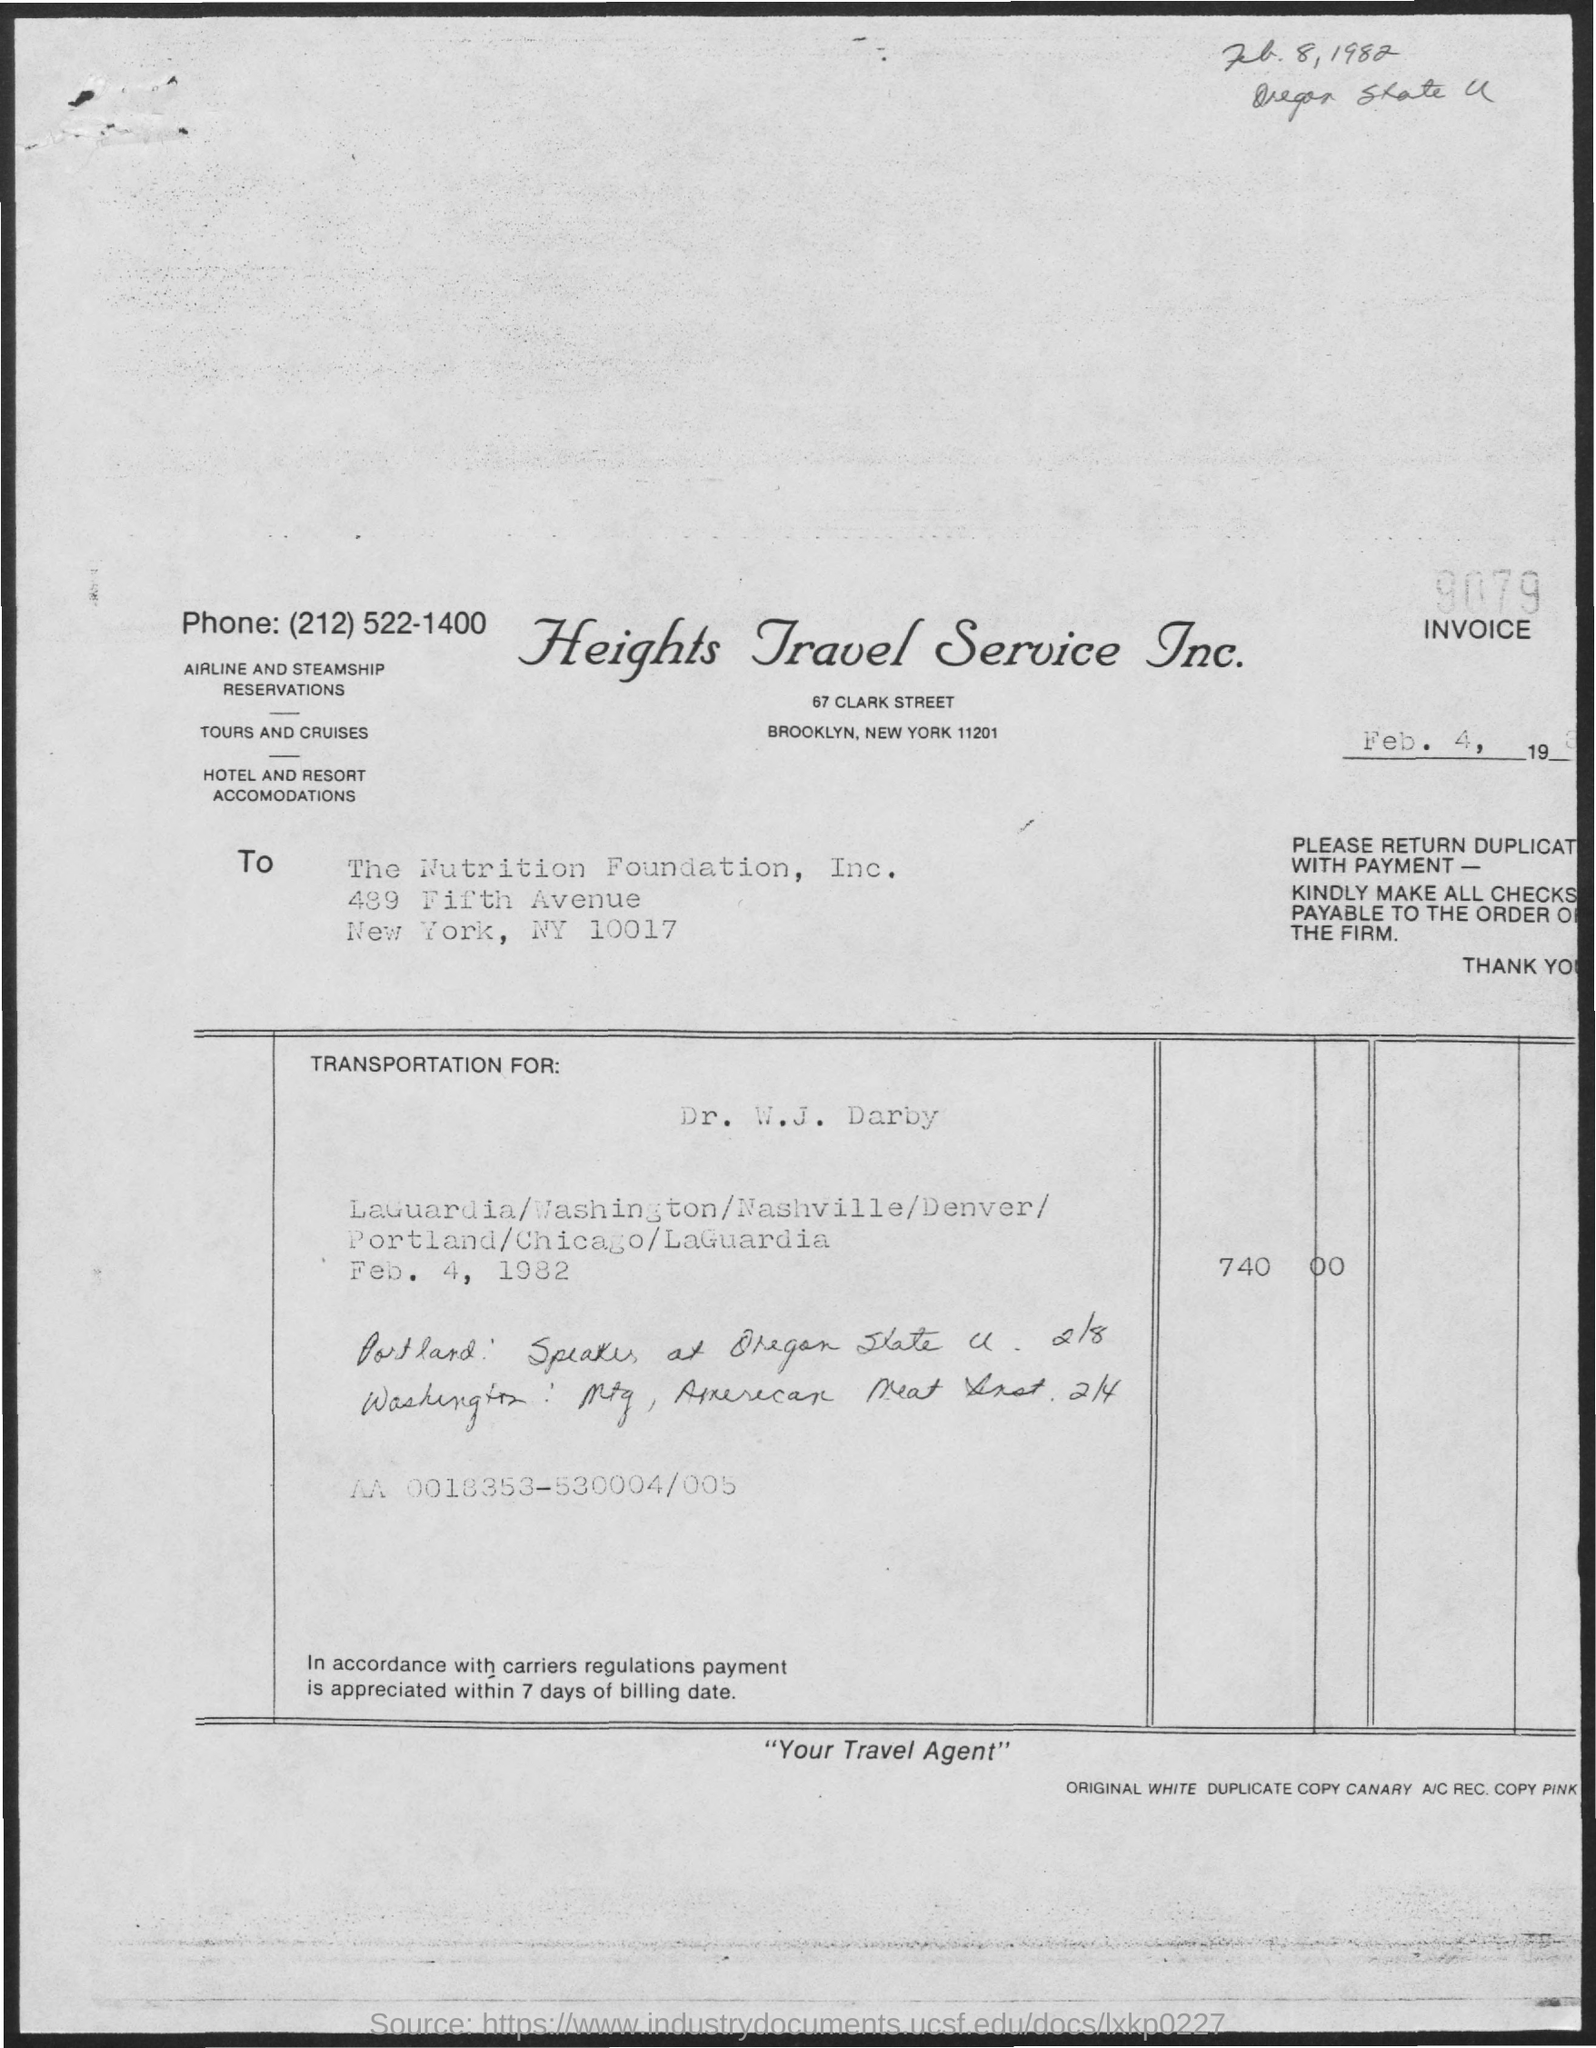What is the Invoice No.?
Your answer should be compact. 9079. What is the date mentioned inside the box?
Ensure brevity in your answer.  Feb. 4, 1982. What is the handwritten date mentioned at the top of the document?
Your response must be concise. Feb. 8,1982. What is the title of the document?
Provide a succinct answer. Heights Travel Service Inc. 